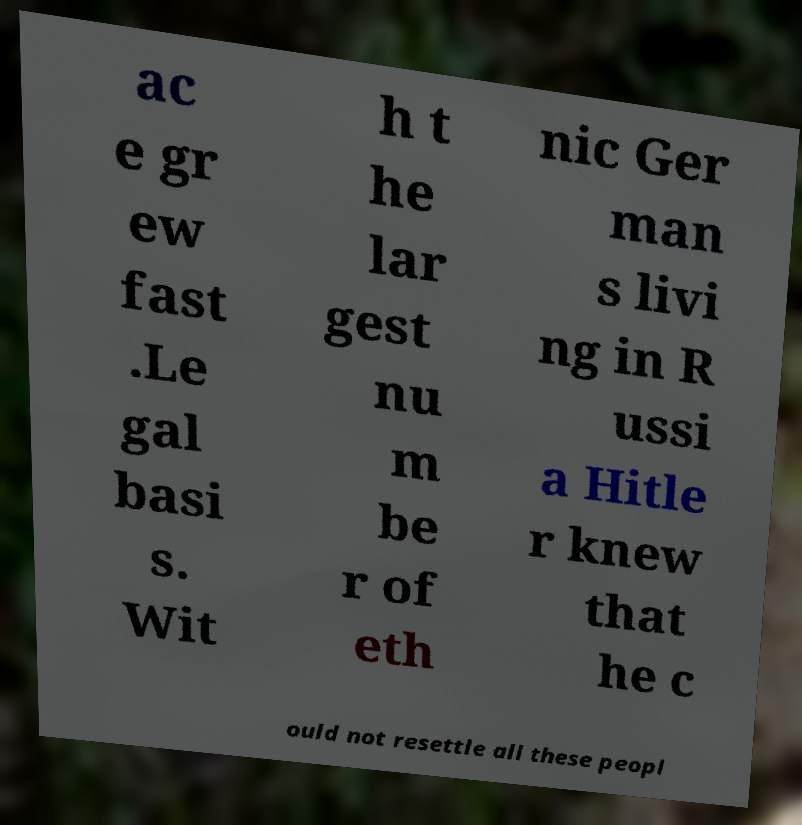Can you accurately transcribe the text from the provided image for me? ac e gr ew fast .Le gal basi s. Wit h t he lar gest nu m be r of eth nic Ger man s livi ng in R ussi a Hitle r knew that he c ould not resettle all these peopl 